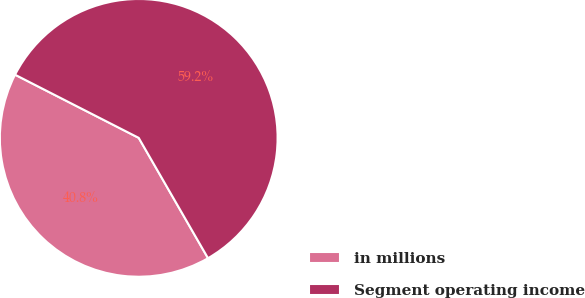<chart> <loc_0><loc_0><loc_500><loc_500><pie_chart><fcel>in millions<fcel>Segment operating income<nl><fcel>40.83%<fcel>59.17%<nl></chart> 